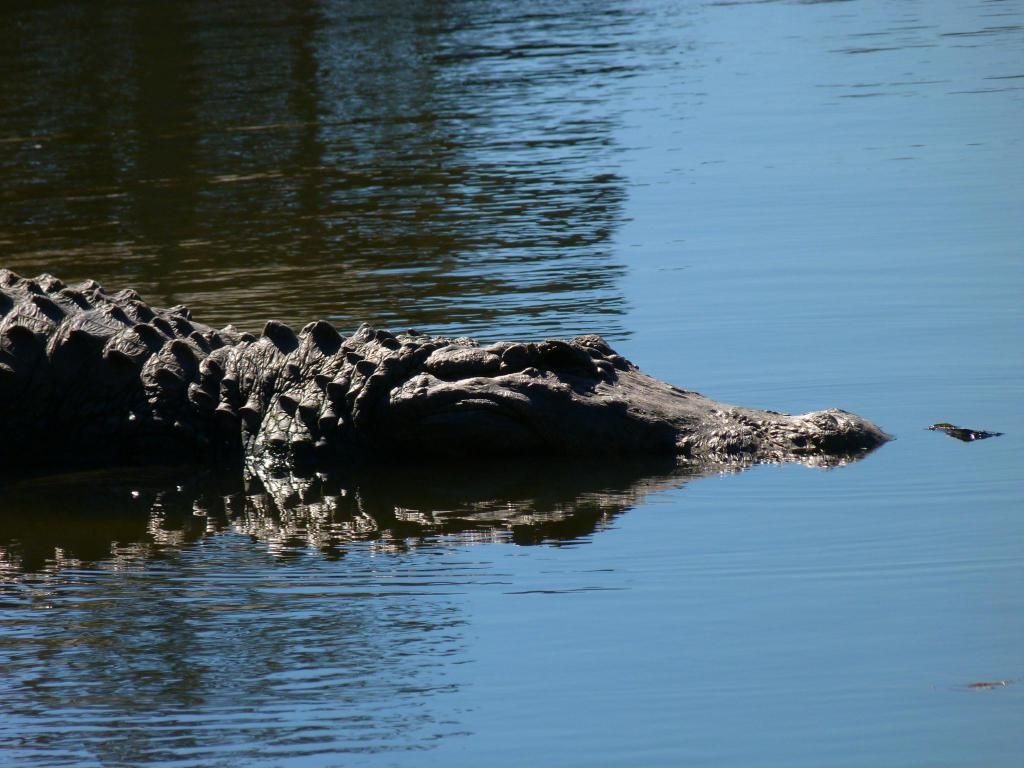What is visible in the image? Water is visible in the image. Is there any wildlife present in the image? Yes, there is a crocodile in the image, positioned towards the left. What type of band can be heard playing music in the image? There is no band present in the image, as it features water and a crocodile. What sound does the crocodile make in the image? The image does not depict any sounds, so it is not possible to determine what sound the crocodile might make. 